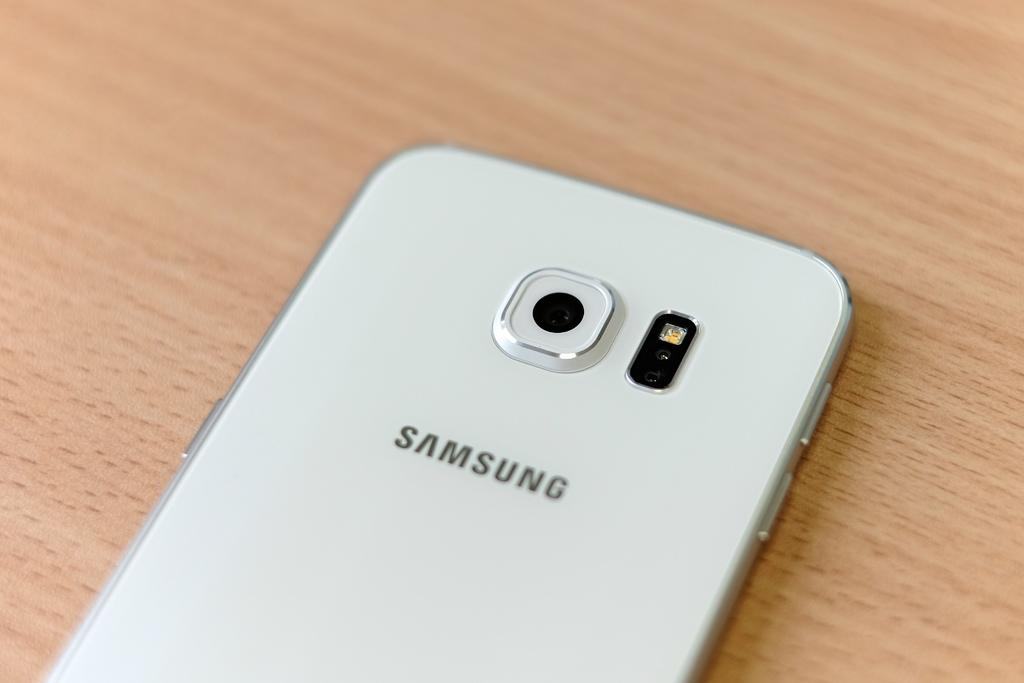<image>
Summarize the visual content of the image. The back of a white Samsung smartphone is shown laying on a wood surface. 